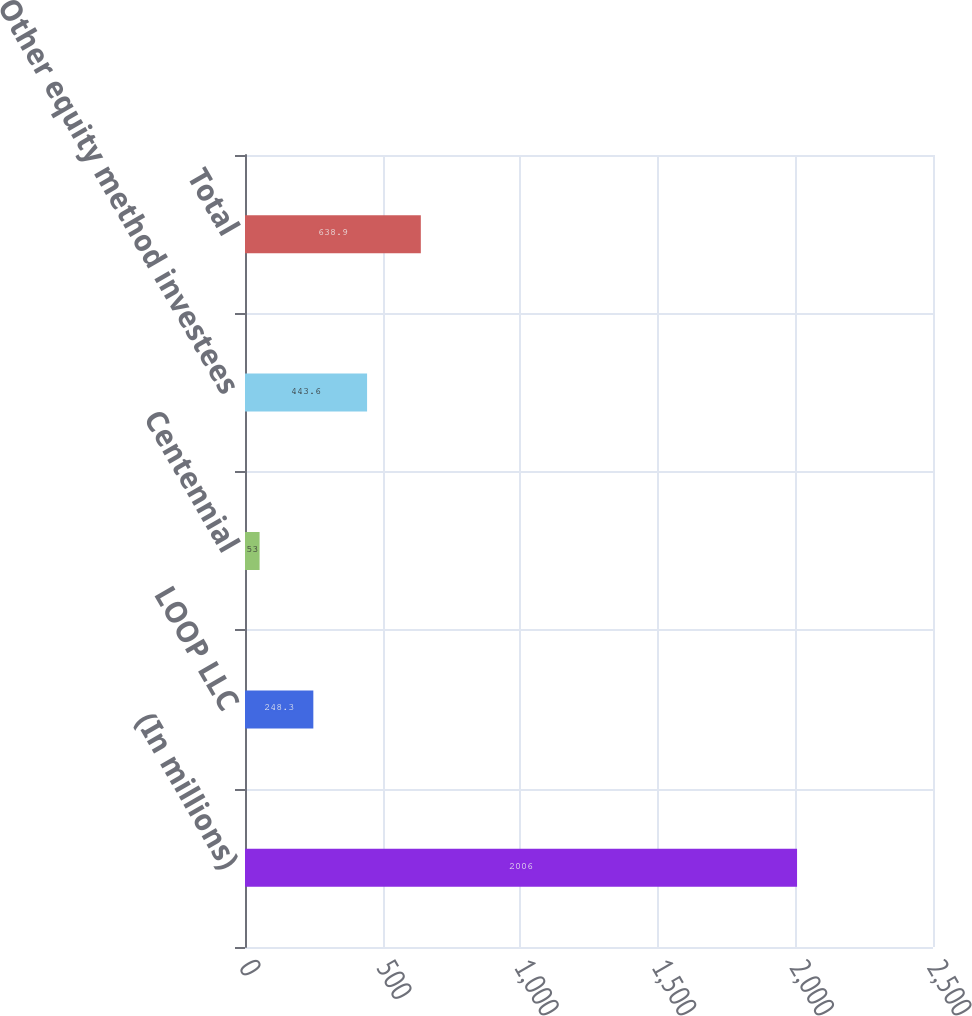Convert chart. <chart><loc_0><loc_0><loc_500><loc_500><bar_chart><fcel>(In millions)<fcel>LOOP LLC<fcel>Centennial<fcel>Other equity method investees<fcel>Total<nl><fcel>2006<fcel>248.3<fcel>53<fcel>443.6<fcel>638.9<nl></chart> 